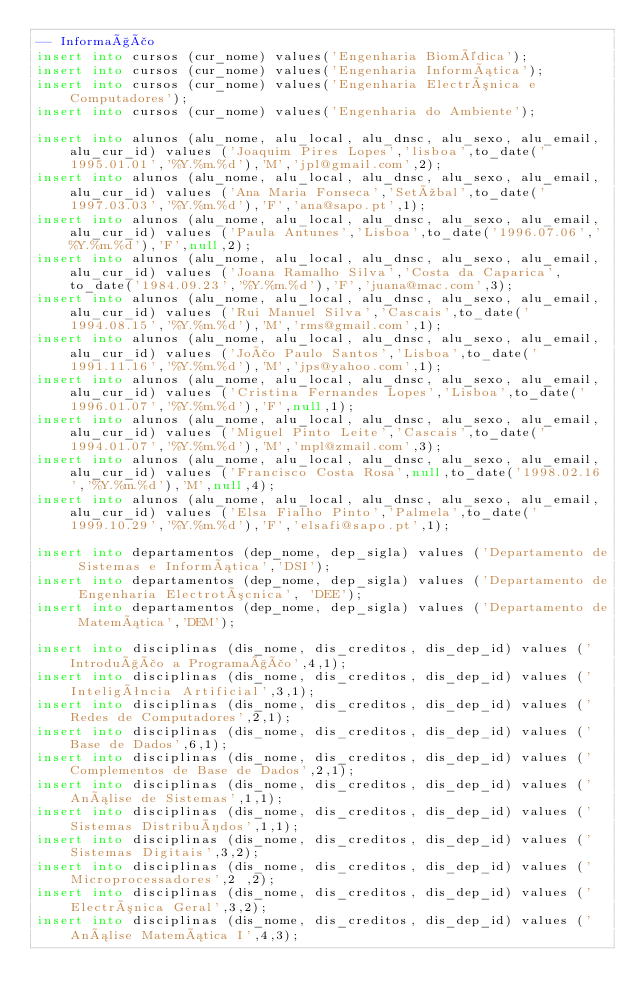Convert code to text. <code><loc_0><loc_0><loc_500><loc_500><_SQL_>-- Informação
insert into cursos (cur_nome) values('Engenharia Biomédica');
insert into cursos (cur_nome) values('Engenharia Informática');
insert into cursos (cur_nome) values('Engenharia Electrónica e Computadores');
insert into cursos (cur_nome) values('Engenharia do Ambiente');
                        
insert into alunos (alu_nome, alu_local, alu_dnsc, alu_sexo, alu_email, alu_cur_id) values ('Joaquim Pires Lopes','lisboa',to_date('1995.01.01','%Y.%m.%d'),'M','jpl@gmail.com',2);  
insert into alunos (alu_nome, alu_local, alu_dnsc, alu_sexo, alu_email, alu_cur_id) values ('Ana Maria Fonseca','Setúbal',to_date('1997.03.03','%Y.%m.%d'),'F','ana@sapo.pt',1);  
insert into alunos (alu_nome, alu_local, alu_dnsc, alu_sexo, alu_email, alu_cur_id) values ('Paula Antunes','Lisboa',to_date('1996.07.06','%Y.%m.%d'),'F',null,2);  
insert into alunos (alu_nome, alu_local, alu_dnsc, alu_sexo, alu_email, alu_cur_id) values ('Joana Ramalho Silva','Costa da Caparica',to_date('1984.09.23','%Y.%m.%d'),'F','juana@mac.com',3);  
insert into alunos (alu_nome, alu_local, alu_dnsc, alu_sexo, alu_email, alu_cur_id) values ('Rui Manuel Silva','Cascais',to_date('1994.08.15','%Y.%m.%d'),'M','rms@gmail.com',1);  
insert into alunos (alu_nome, alu_local, alu_dnsc, alu_sexo, alu_email, alu_cur_id) values ('João Paulo Santos','Lisboa',to_date('1991.11.16','%Y.%m.%d'),'M','jps@yahoo.com',1);  
insert into alunos (alu_nome, alu_local, alu_dnsc, alu_sexo, alu_email, alu_cur_id) values ('Cristina Fernandes Lopes','Lisboa',to_date('1996.01.07','%Y.%m.%d'),'F',null,1);  
insert into alunos (alu_nome, alu_local, alu_dnsc, alu_sexo, alu_email, alu_cur_id) values ('Miguel Pinto Leite','Cascais',to_date('1994.01.07','%Y.%m.%d'),'M','mpl@zmail.com',3);  
insert into alunos (alu_nome, alu_local, alu_dnsc, alu_sexo, alu_email, alu_cur_id) values ('Francisco Costa Rosa',null,to_date('1998.02.16','%Y.%m.%d'),'M',null,4);  
insert into alunos (alu_nome, alu_local, alu_dnsc, alu_sexo, alu_email, alu_cur_id) values ('Elsa Fialho Pinto','Palmela',to_date('1999.10.29','%Y.%m.%d'),'F','elsafi@sapo.pt',1);  
                        
insert into departamentos (dep_nome, dep_sigla) values ('Departamento de Sistemas e Informática','DSI');
insert into departamentos (dep_nome, dep_sigla) values ('Departamento de Engenharia Electrotócnica', 'DEE');
insert into departamentos (dep_nome, dep_sigla) values ('Departamento de Matemática','DEM');    

insert into disciplinas (dis_nome, dis_creditos, dis_dep_id) values ('Introdução a Programação',4,1);
insert into disciplinas (dis_nome, dis_creditos, dis_dep_id) values ('Inteligência Artificial',3,1);
insert into disciplinas (dis_nome, dis_creditos, dis_dep_id) values ('Redes de Computadores',2,1);
insert into disciplinas (dis_nome, dis_creditos, dis_dep_id) values ('Base de Dados',6,1);
insert into disciplinas (dis_nome, dis_creditos, dis_dep_id) values ('Complementos de Base de Dados',2,1);
insert into disciplinas (dis_nome, dis_creditos, dis_dep_id) values ('Análise de Sistemas',1,1);
insert into disciplinas (dis_nome, dis_creditos, dis_dep_id) values ('Sistemas Distribuídos',1,1);
insert into disciplinas (dis_nome, dis_creditos, dis_dep_id) values ('Sistemas Digitais',3,2);
insert into disciplinas (dis_nome, dis_creditos, dis_dep_id) values ('Microprocessadores',2 ,2);
insert into disciplinas (dis_nome, dis_creditos, dis_dep_id) values ('Electrónica Geral',3,2);
insert into disciplinas (dis_nome, dis_creditos, dis_dep_id) values ('Análise Matemática I',4,3);</code> 